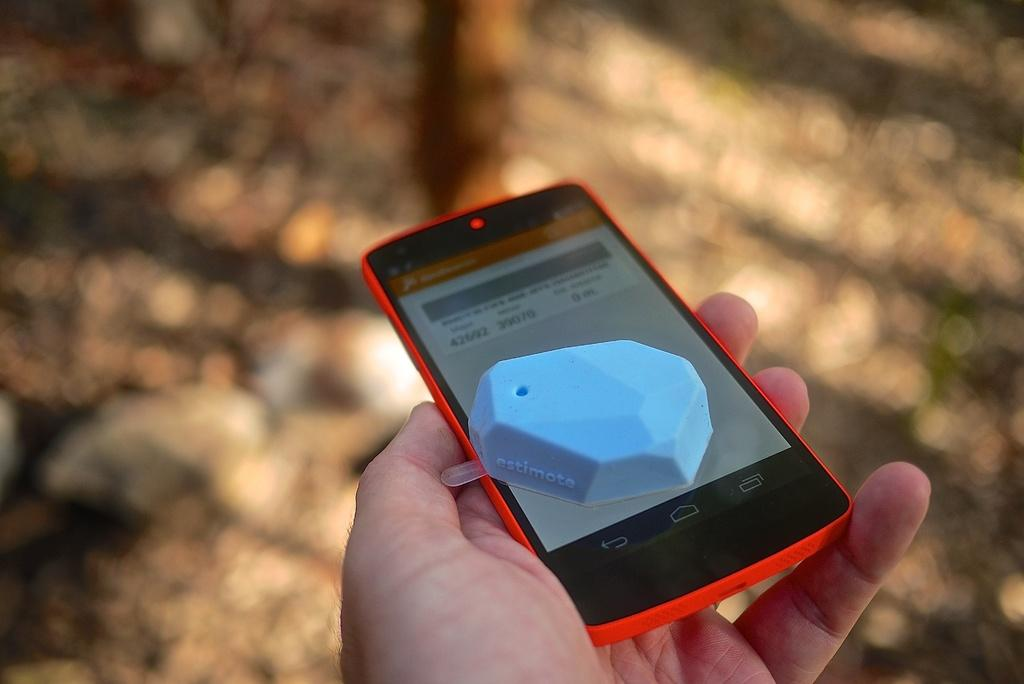Provide a one-sentence caption for the provided image. A person is holding a cell phone with a blue object on top that says "estimote" on it. 